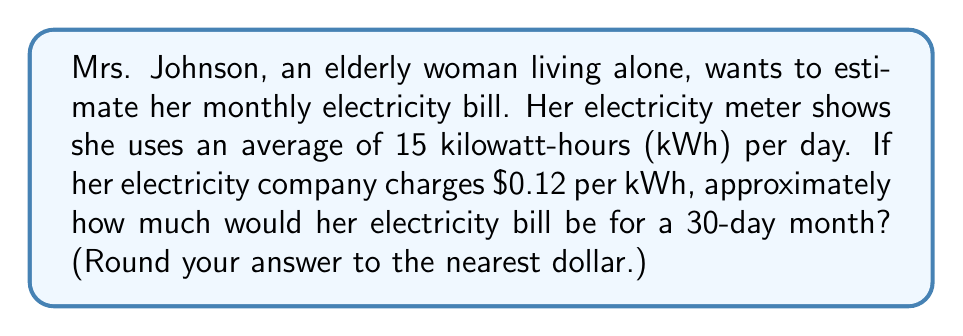Can you solve this math problem? Let's break this problem down into simple steps:

1. Calculate the total kWh used in a month:
   $$ \text{Monthly usage} = \text{Daily usage} \times \text{Number of days} $$
   $$ \text{Monthly usage} = 15 \text{ kWh} \times 30 \text{ days} = 450 \text{ kWh} $$

2. Calculate the cost of electricity:
   $$ \text{Cost} = \text{Monthly usage} \times \text{Price per kWh} $$
   $$ \text{Cost} = 450 \text{ kWh} \times \$0.12/\text{kWh} = \$54 $$

3. Round to the nearest dollar:
   The result is already a whole number, so no rounding is necessary.

Therefore, Mrs. Johnson's estimated monthly electricity bill would be $54.
Answer: $54 